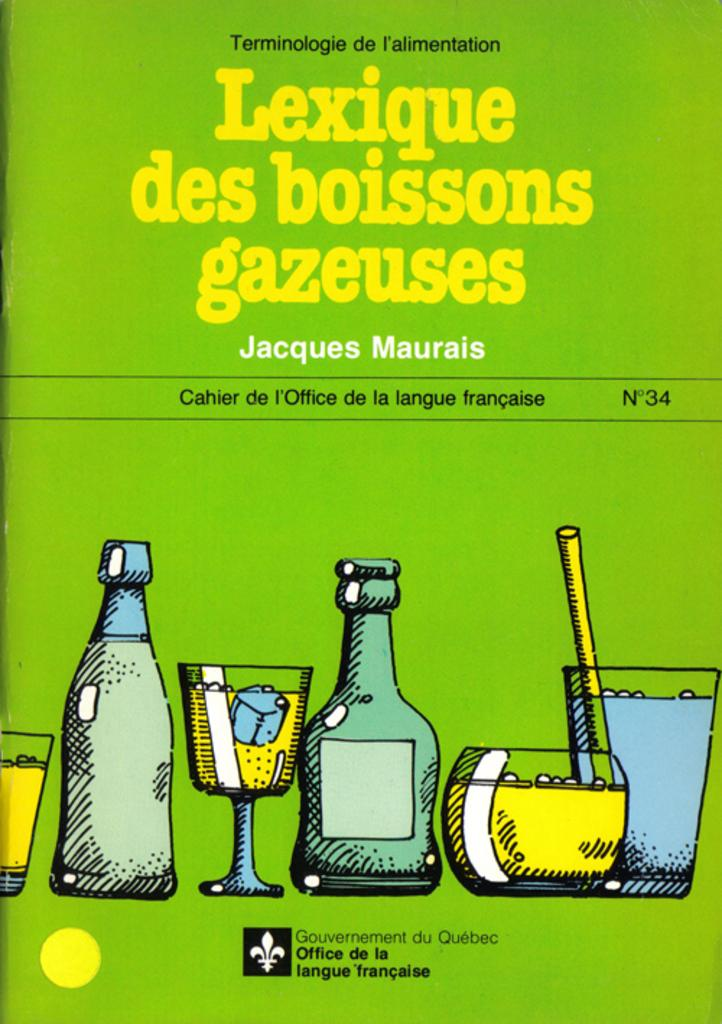<image>
Write a terse but informative summary of the picture. A green book with the foregn title Lexique des boisson gazesus. 